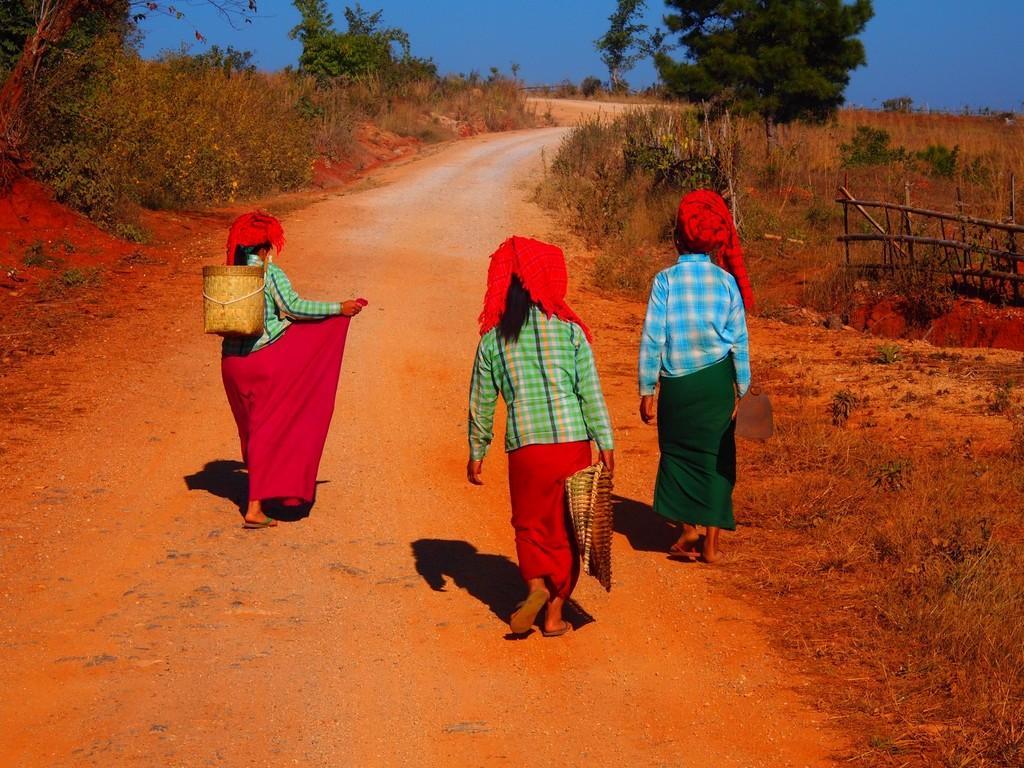In one or two sentences, can you explain what this image depicts? In this picture I can see there are three people walking and they are wearing basket and there are trees in the backdrop. The sky is clear. 